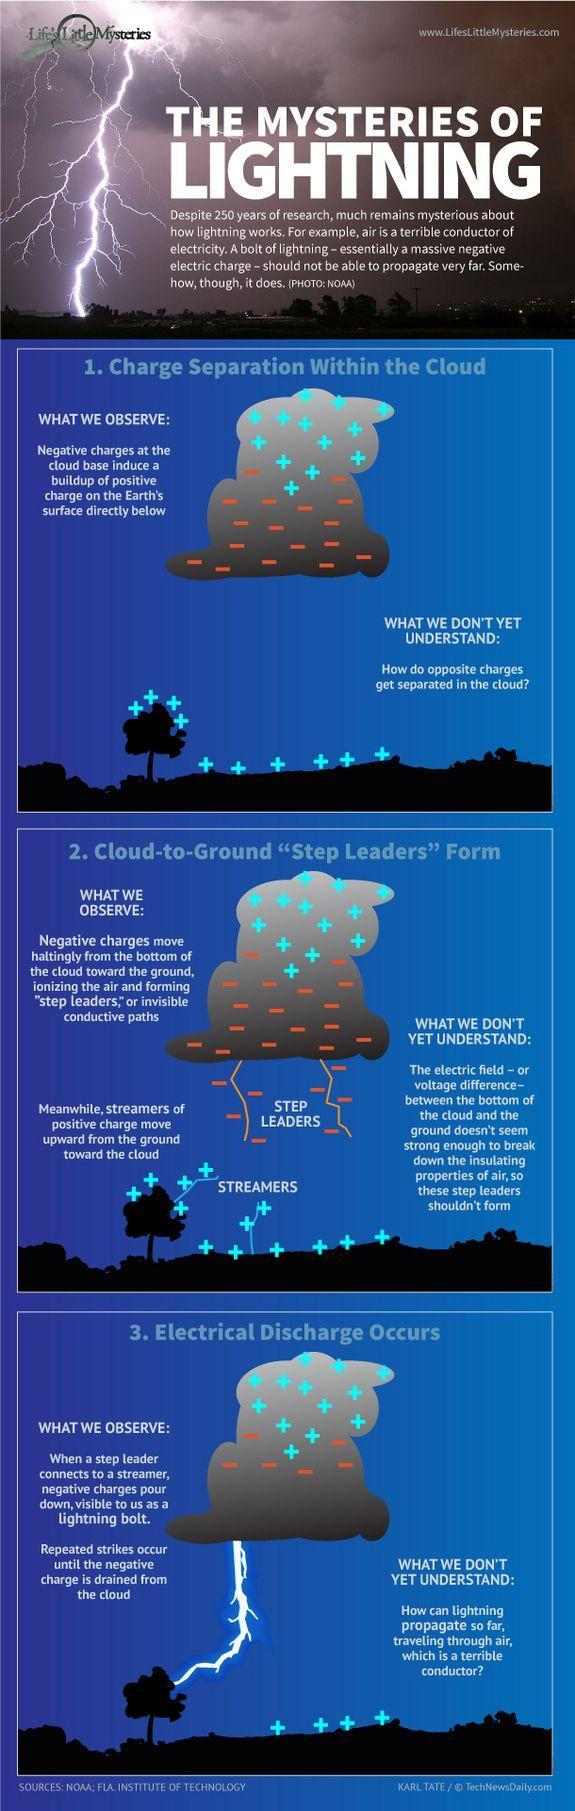What are cations that move up towards the sky called?
Answer the question with a short phrase. STREAMERS What is an anion that move towards the earth called? STEP LEADERS 